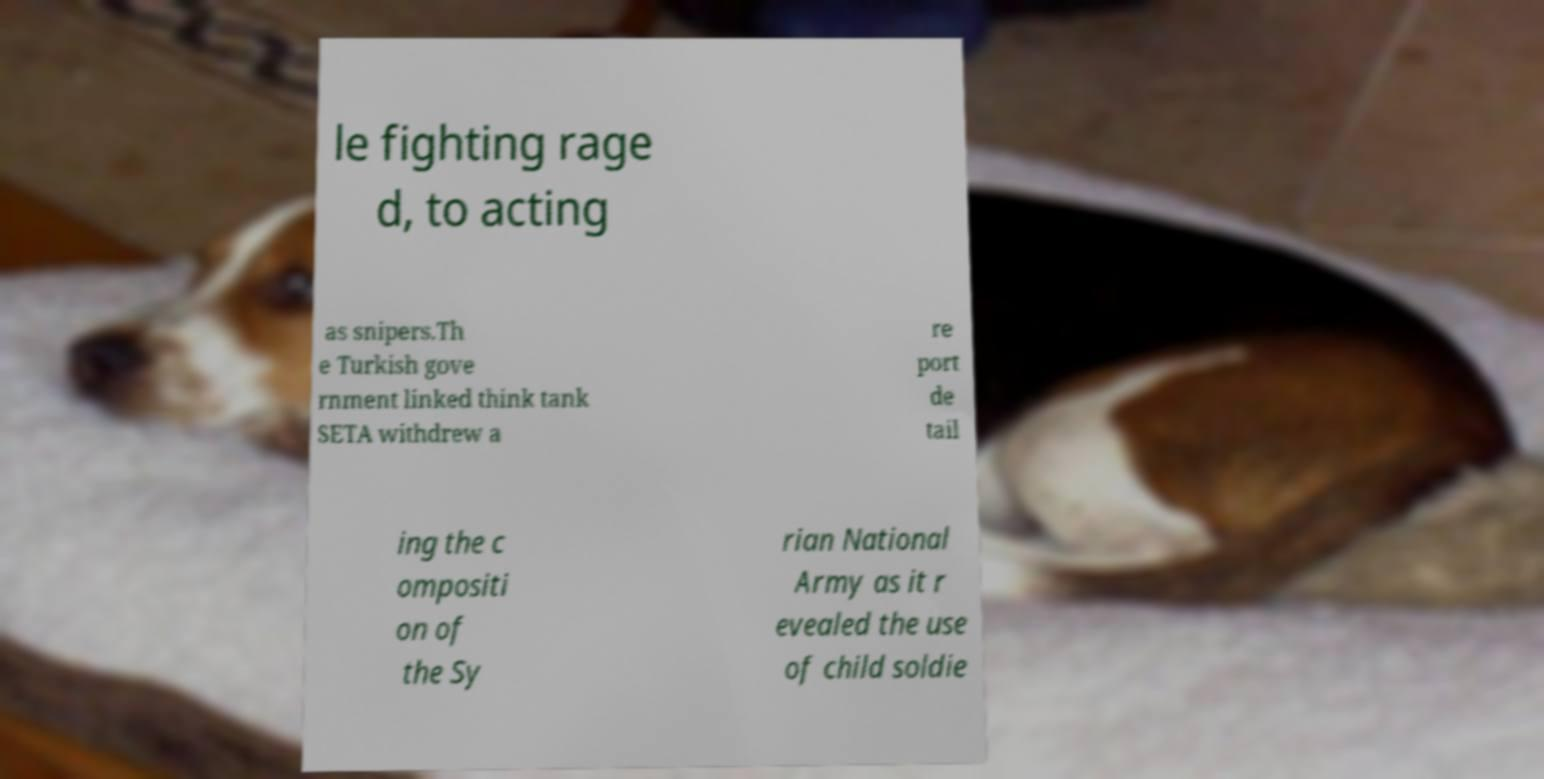There's text embedded in this image that I need extracted. Can you transcribe it verbatim? le fighting rage d, to acting as snipers.Th e Turkish gove rnment linked think tank SETA withdrew a re port de tail ing the c ompositi on of the Sy rian National Army as it r evealed the use of child soldie 